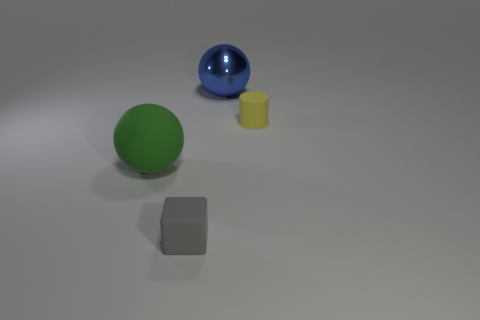What size is the metal thing that is the same shape as the large rubber thing?
Offer a very short reply. Large. Is there anything else that has the same material as the gray thing?
Your answer should be compact. Yes. There is a big ball that is left of the large thing behind the yellow rubber cylinder that is right of the shiny ball; what is its material?
Make the answer very short. Rubber. Is the shape of the green matte thing the same as the tiny yellow rubber thing?
Your response must be concise. No. What is the material of the large green object that is the same shape as the large blue metallic thing?
Provide a short and direct response. Rubber. How many small rubber blocks have the same color as the cylinder?
Give a very brief answer. 0. What size is the cube that is made of the same material as the green thing?
Offer a terse response. Small. How many blue things are either cylinders or tiny objects?
Provide a short and direct response. 0. There is a matte object to the left of the gray block; what number of rubber things are right of it?
Offer a terse response. 2. Are there more small yellow matte cylinders that are in front of the small yellow cylinder than tiny yellow matte cylinders that are right of the tiny matte block?
Your answer should be very brief. No. 